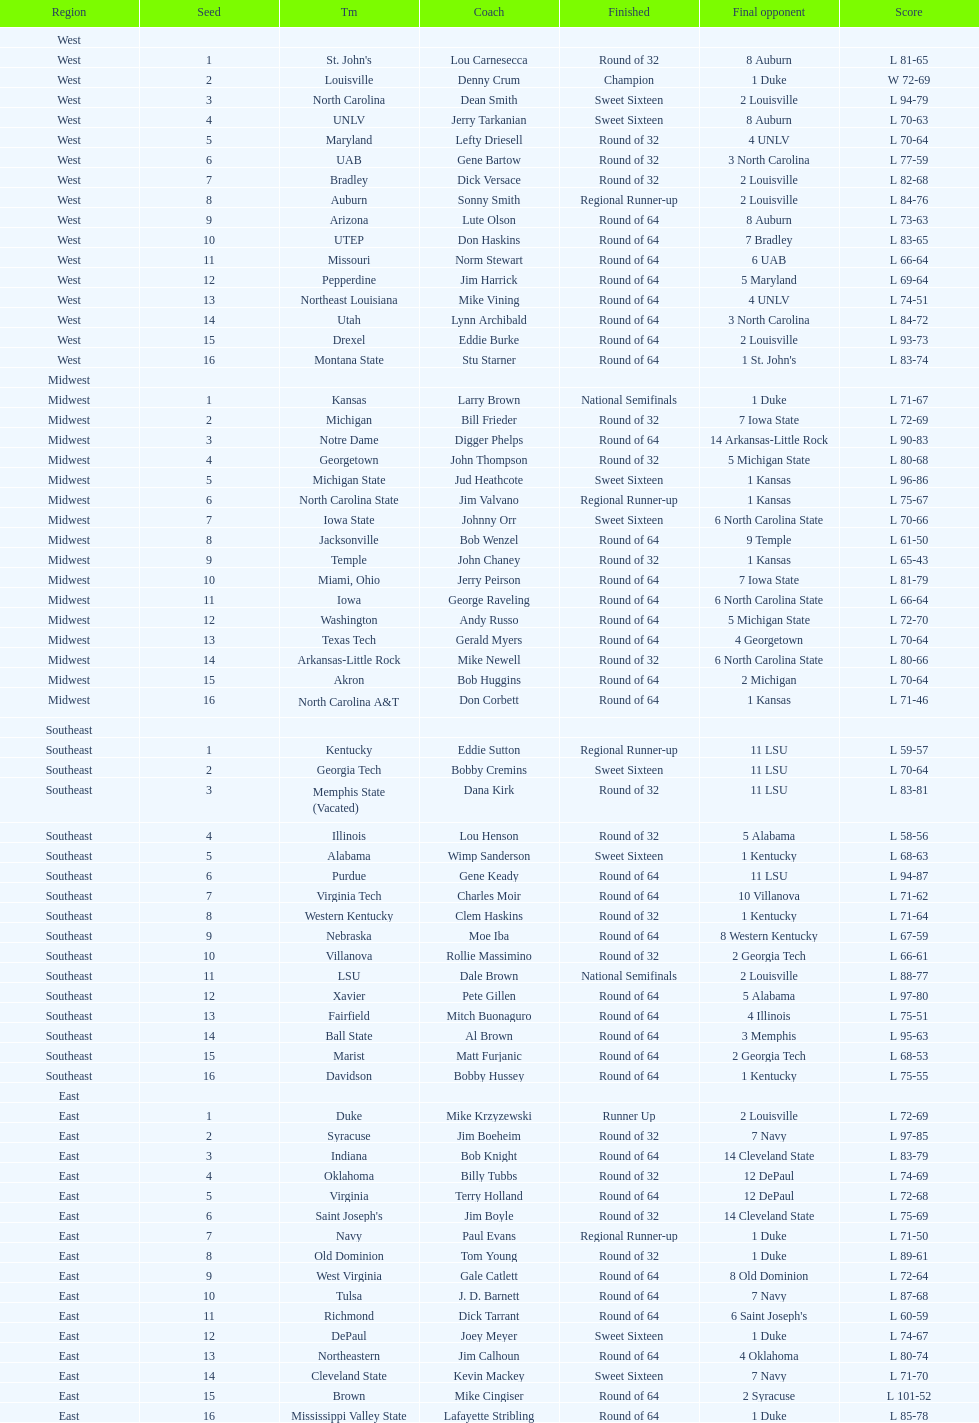Who was the only champion? Louisville. 